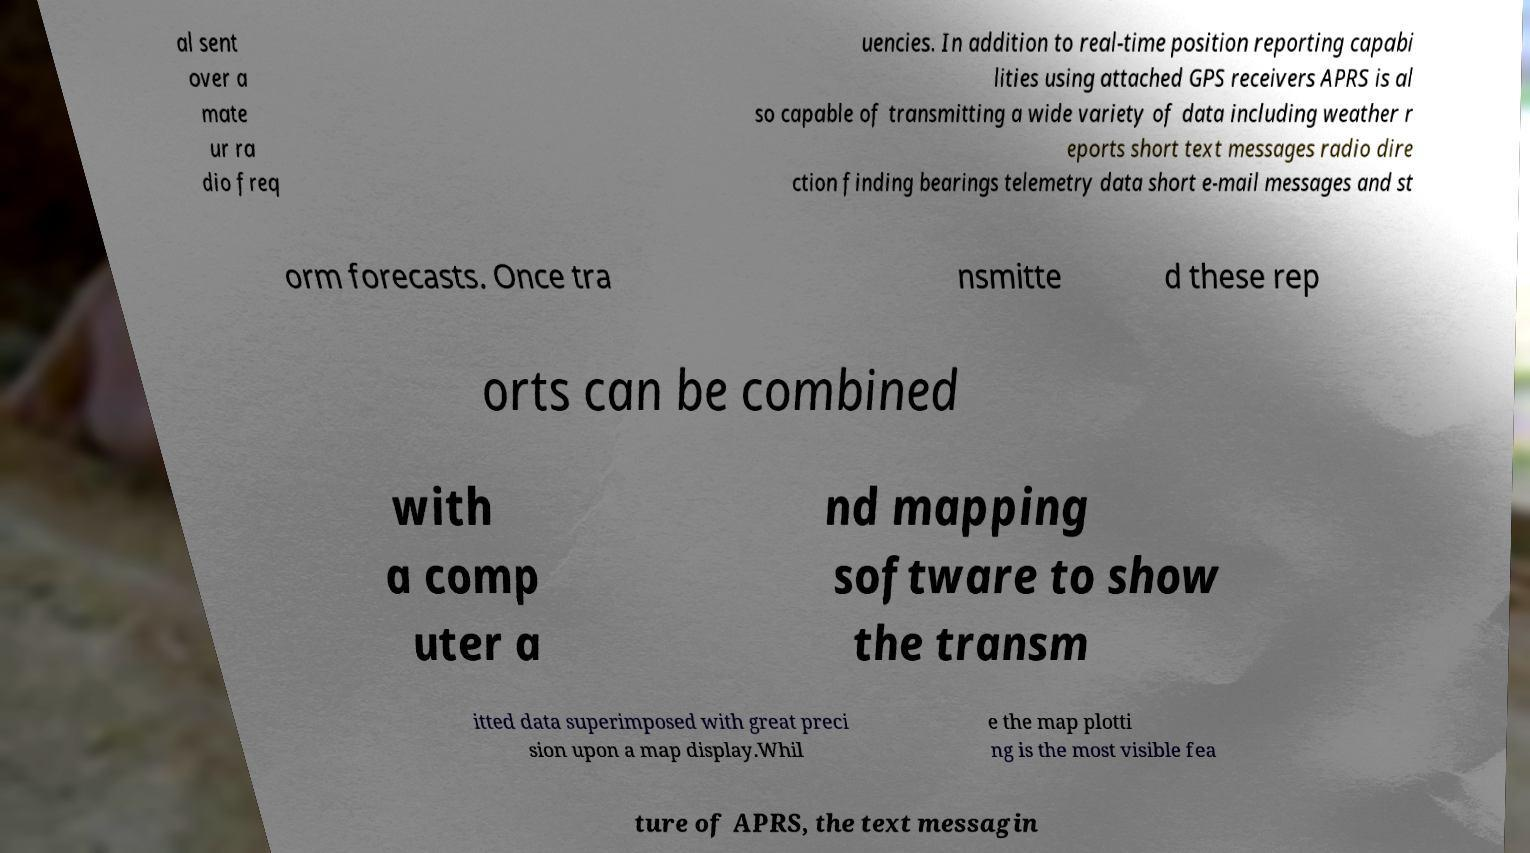Could you extract and type out the text from this image? al sent over a mate ur ra dio freq uencies. In addition to real-time position reporting capabi lities using attached GPS receivers APRS is al so capable of transmitting a wide variety of data including weather r eports short text messages radio dire ction finding bearings telemetry data short e-mail messages and st orm forecasts. Once tra nsmitte d these rep orts can be combined with a comp uter a nd mapping software to show the transm itted data superimposed with great preci sion upon a map display.Whil e the map plotti ng is the most visible fea ture of APRS, the text messagin 